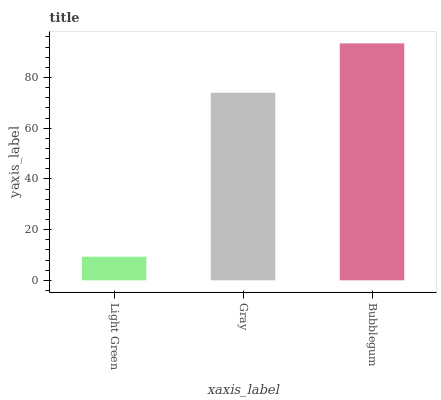Is Light Green the minimum?
Answer yes or no. Yes. Is Bubblegum the maximum?
Answer yes or no. Yes. Is Gray the minimum?
Answer yes or no. No. Is Gray the maximum?
Answer yes or no. No. Is Gray greater than Light Green?
Answer yes or no. Yes. Is Light Green less than Gray?
Answer yes or no. Yes. Is Light Green greater than Gray?
Answer yes or no. No. Is Gray less than Light Green?
Answer yes or no. No. Is Gray the high median?
Answer yes or no. Yes. Is Gray the low median?
Answer yes or no. Yes. Is Light Green the high median?
Answer yes or no. No. Is Light Green the low median?
Answer yes or no. No. 